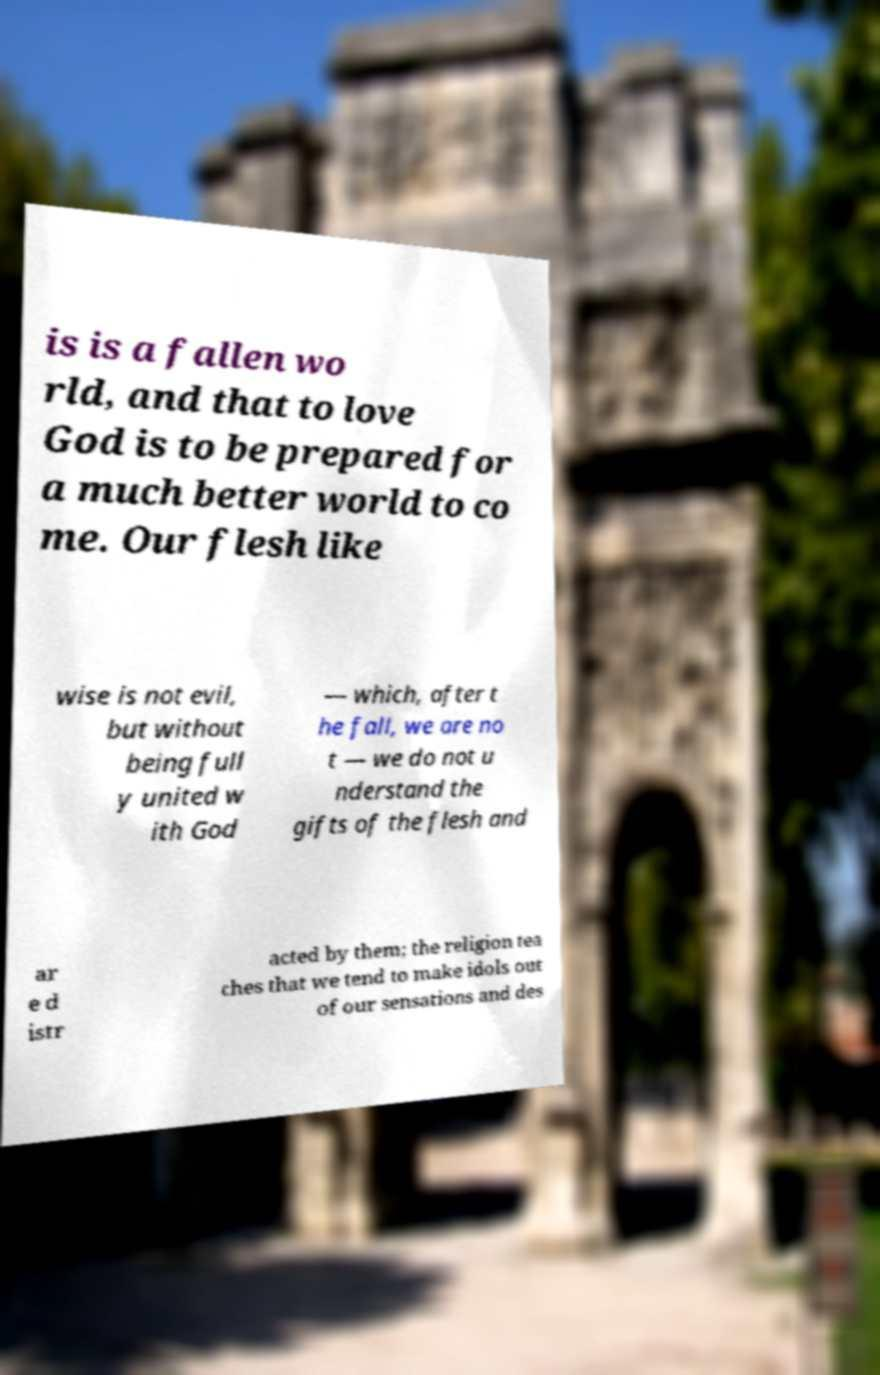Can you read and provide the text displayed in the image?This photo seems to have some interesting text. Can you extract and type it out for me? is is a fallen wo rld, and that to love God is to be prepared for a much better world to co me. Our flesh like wise is not evil, but without being full y united w ith God — which, after t he fall, we are no t — we do not u nderstand the gifts of the flesh and ar e d istr acted by them; the religion tea ches that we tend to make idols out of our sensations and des 